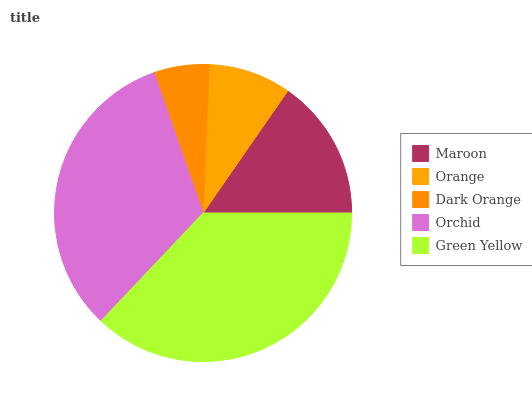Is Dark Orange the minimum?
Answer yes or no. Yes. Is Green Yellow the maximum?
Answer yes or no. Yes. Is Orange the minimum?
Answer yes or no. No. Is Orange the maximum?
Answer yes or no. No. Is Maroon greater than Orange?
Answer yes or no. Yes. Is Orange less than Maroon?
Answer yes or no. Yes. Is Orange greater than Maroon?
Answer yes or no. No. Is Maroon less than Orange?
Answer yes or no. No. Is Maroon the high median?
Answer yes or no. Yes. Is Maroon the low median?
Answer yes or no. Yes. Is Orange the high median?
Answer yes or no. No. Is Orange the low median?
Answer yes or no. No. 